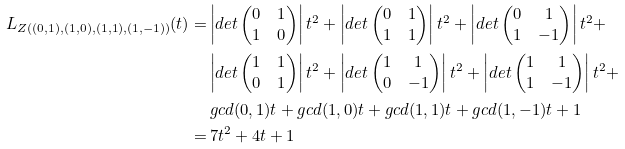Convert formula to latex. <formula><loc_0><loc_0><loc_500><loc_500>L _ { Z ( ( 0 , 1 ) , ( 1 , 0 ) , ( 1 , 1 ) , ( 1 , - 1 ) ) } ( t ) = & \left | d e t \begin{pmatrix} 0 & 1 \\ 1 & 0 \end{pmatrix} \right | t ^ { 2 } + \left | d e t \begin{pmatrix} 0 & 1 \\ 1 & 1 \end{pmatrix} \right | t ^ { 2 } + \left | d e t \begin{pmatrix} 0 & 1 \\ 1 & - 1 \end{pmatrix} \right | t ^ { 2 } + \\ & \left | d e t \begin{pmatrix} 1 & 1 \\ 0 & 1 \end{pmatrix} \right | t ^ { 2 } + \left | d e t \begin{pmatrix} 1 & 1 \\ 0 & - 1 \end{pmatrix} \right | t ^ { 2 } + \left | d e t \begin{pmatrix} 1 & 1 \\ 1 & - 1 \end{pmatrix} \right | t ^ { 2 } + \\ & \, g c d ( 0 , 1 ) t + g c d ( 1 , 0 ) t + g c d ( 1 , 1 ) t + g c d ( 1 , - 1 ) t + 1 \\ = & \, 7 t ^ { 2 } + 4 t + 1</formula> 